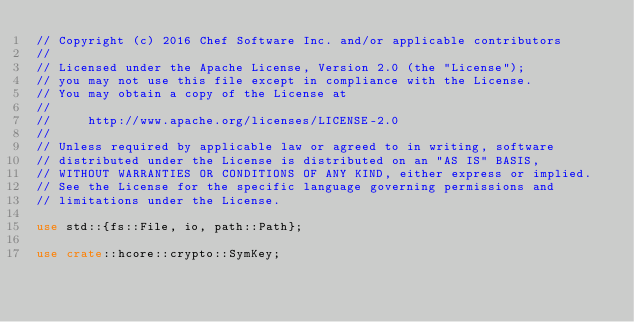Convert code to text. <code><loc_0><loc_0><loc_500><loc_500><_Rust_>// Copyright (c) 2016 Chef Software Inc. and/or applicable contributors
//
// Licensed under the Apache License, Version 2.0 (the "License");
// you may not use this file except in compliance with the License.
// You may obtain a copy of the License at
//
//     http://www.apache.org/licenses/LICENSE-2.0
//
// Unless required by applicable law or agreed to in writing, software
// distributed under the License is distributed on an "AS IS" BASIS,
// WITHOUT WARRANTIES OR CONDITIONS OF ANY KIND, either express or implied.
// See the License for the specific language governing permissions and
// limitations under the License.

use std::{fs::File, io, path::Path};

use crate::hcore::crypto::SymKey;
</code> 